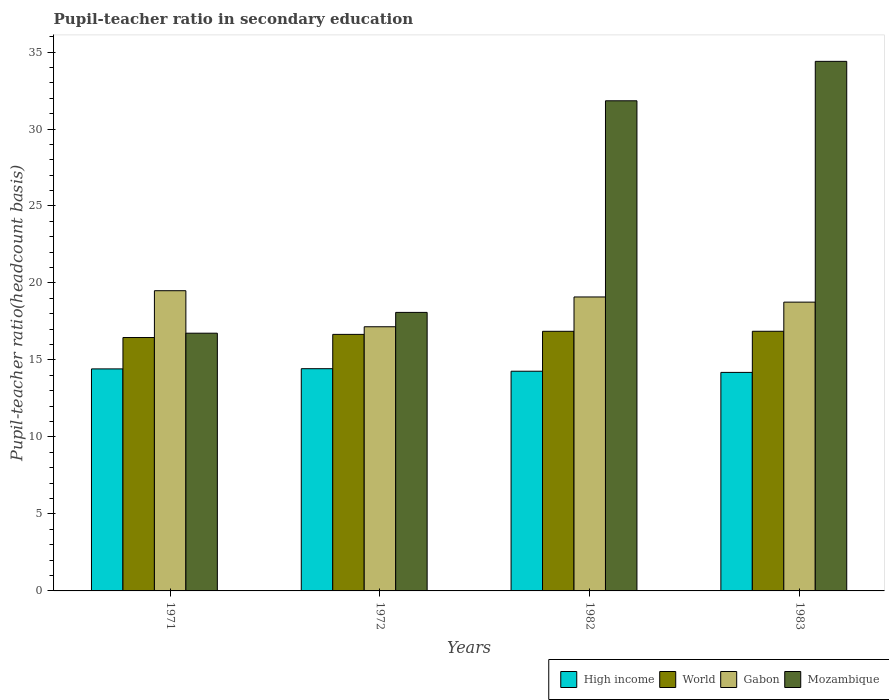How many different coloured bars are there?
Provide a succinct answer. 4. How many groups of bars are there?
Make the answer very short. 4. Are the number of bars on each tick of the X-axis equal?
Offer a very short reply. Yes. How many bars are there on the 3rd tick from the left?
Provide a short and direct response. 4. How many bars are there on the 2nd tick from the right?
Your response must be concise. 4. What is the label of the 2nd group of bars from the left?
Ensure brevity in your answer.  1972. What is the pupil-teacher ratio in secondary education in Mozambique in 1982?
Provide a short and direct response. 31.83. Across all years, what is the maximum pupil-teacher ratio in secondary education in World?
Ensure brevity in your answer.  16.86. Across all years, what is the minimum pupil-teacher ratio in secondary education in Mozambique?
Keep it short and to the point. 16.74. In which year was the pupil-teacher ratio in secondary education in Mozambique minimum?
Your answer should be compact. 1971. What is the total pupil-teacher ratio in secondary education in Mozambique in the graph?
Your response must be concise. 101.05. What is the difference between the pupil-teacher ratio in secondary education in High income in 1982 and that in 1983?
Ensure brevity in your answer.  0.08. What is the difference between the pupil-teacher ratio in secondary education in Gabon in 1972 and the pupil-teacher ratio in secondary education in World in 1983?
Offer a terse response. 0.29. What is the average pupil-teacher ratio in secondary education in Gabon per year?
Provide a succinct answer. 18.63. In the year 1982, what is the difference between the pupil-teacher ratio in secondary education in Gabon and pupil-teacher ratio in secondary education in World?
Offer a very short reply. 2.23. In how many years, is the pupil-teacher ratio in secondary education in World greater than 34?
Ensure brevity in your answer.  0. What is the ratio of the pupil-teacher ratio in secondary education in High income in 1972 to that in 1982?
Your answer should be very brief. 1.01. Is the pupil-teacher ratio in secondary education in High income in 1971 less than that in 1983?
Provide a succinct answer. No. Is the difference between the pupil-teacher ratio in secondary education in Gabon in 1971 and 1983 greater than the difference between the pupil-teacher ratio in secondary education in World in 1971 and 1983?
Make the answer very short. Yes. What is the difference between the highest and the second highest pupil-teacher ratio in secondary education in High income?
Offer a very short reply. 0.01. What is the difference between the highest and the lowest pupil-teacher ratio in secondary education in Mozambique?
Keep it short and to the point. 17.66. In how many years, is the pupil-teacher ratio in secondary education in High income greater than the average pupil-teacher ratio in secondary education in High income taken over all years?
Offer a terse response. 2. Is the sum of the pupil-teacher ratio in secondary education in High income in 1972 and 1982 greater than the maximum pupil-teacher ratio in secondary education in Mozambique across all years?
Your answer should be very brief. No. What does the 4th bar from the left in 1982 represents?
Offer a very short reply. Mozambique. Is it the case that in every year, the sum of the pupil-teacher ratio in secondary education in World and pupil-teacher ratio in secondary education in High income is greater than the pupil-teacher ratio in secondary education in Gabon?
Ensure brevity in your answer.  Yes. Are the values on the major ticks of Y-axis written in scientific E-notation?
Your response must be concise. No. Does the graph contain any zero values?
Your answer should be very brief. No. Does the graph contain grids?
Offer a terse response. No. How are the legend labels stacked?
Ensure brevity in your answer.  Horizontal. What is the title of the graph?
Provide a short and direct response. Pupil-teacher ratio in secondary education. Does "Tanzania" appear as one of the legend labels in the graph?
Your answer should be compact. No. What is the label or title of the X-axis?
Keep it short and to the point. Years. What is the label or title of the Y-axis?
Your answer should be compact. Pupil-teacher ratio(headcount basis). What is the Pupil-teacher ratio(headcount basis) of High income in 1971?
Ensure brevity in your answer.  14.42. What is the Pupil-teacher ratio(headcount basis) in World in 1971?
Give a very brief answer. 16.46. What is the Pupil-teacher ratio(headcount basis) of Gabon in 1971?
Your response must be concise. 19.5. What is the Pupil-teacher ratio(headcount basis) in Mozambique in 1971?
Keep it short and to the point. 16.74. What is the Pupil-teacher ratio(headcount basis) in High income in 1972?
Your answer should be very brief. 14.43. What is the Pupil-teacher ratio(headcount basis) in World in 1972?
Keep it short and to the point. 16.66. What is the Pupil-teacher ratio(headcount basis) in Gabon in 1972?
Give a very brief answer. 17.16. What is the Pupil-teacher ratio(headcount basis) of Mozambique in 1972?
Provide a short and direct response. 18.09. What is the Pupil-teacher ratio(headcount basis) in High income in 1982?
Offer a very short reply. 14.27. What is the Pupil-teacher ratio(headcount basis) in World in 1982?
Your answer should be compact. 16.86. What is the Pupil-teacher ratio(headcount basis) in Gabon in 1982?
Keep it short and to the point. 19.09. What is the Pupil-teacher ratio(headcount basis) of Mozambique in 1982?
Give a very brief answer. 31.83. What is the Pupil-teacher ratio(headcount basis) of High income in 1983?
Your answer should be very brief. 14.19. What is the Pupil-teacher ratio(headcount basis) of World in 1983?
Ensure brevity in your answer.  16.86. What is the Pupil-teacher ratio(headcount basis) in Gabon in 1983?
Ensure brevity in your answer.  18.76. What is the Pupil-teacher ratio(headcount basis) of Mozambique in 1983?
Give a very brief answer. 34.39. Across all years, what is the maximum Pupil-teacher ratio(headcount basis) of High income?
Offer a very short reply. 14.43. Across all years, what is the maximum Pupil-teacher ratio(headcount basis) in World?
Provide a short and direct response. 16.86. Across all years, what is the maximum Pupil-teacher ratio(headcount basis) in Gabon?
Offer a terse response. 19.5. Across all years, what is the maximum Pupil-teacher ratio(headcount basis) of Mozambique?
Offer a very short reply. 34.39. Across all years, what is the minimum Pupil-teacher ratio(headcount basis) in High income?
Offer a terse response. 14.19. Across all years, what is the minimum Pupil-teacher ratio(headcount basis) of World?
Provide a succinct answer. 16.46. Across all years, what is the minimum Pupil-teacher ratio(headcount basis) in Gabon?
Your answer should be very brief. 17.16. Across all years, what is the minimum Pupil-teacher ratio(headcount basis) in Mozambique?
Ensure brevity in your answer.  16.74. What is the total Pupil-teacher ratio(headcount basis) in High income in the graph?
Provide a succinct answer. 57.31. What is the total Pupil-teacher ratio(headcount basis) in World in the graph?
Make the answer very short. 66.84. What is the total Pupil-teacher ratio(headcount basis) in Gabon in the graph?
Offer a terse response. 74.5. What is the total Pupil-teacher ratio(headcount basis) of Mozambique in the graph?
Your answer should be compact. 101.06. What is the difference between the Pupil-teacher ratio(headcount basis) in High income in 1971 and that in 1972?
Provide a short and direct response. -0.01. What is the difference between the Pupil-teacher ratio(headcount basis) in World in 1971 and that in 1972?
Provide a short and direct response. -0.2. What is the difference between the Pupil-teacher ratio(headcount basis) of Gabon in 1971 and that in 1972?
Ensure brevity in your answer.  2.34. What is the difference between the Pupil-teacher ratio(headcount basis) in Mozambique in 1971 and that in 1972?
Provide a short and direct response. -1.35. What is the difference between the Pupil-teacher ratio(headcount basis) in High income in 1971 and that in 1982?
Provide a succinct answer. 0.15. What is the difference between the Pupil-teacher ratio(headcount basis) of World in 1971 and that in 1982?
Your answer should be very brief. -0.4. What is the difference between the Pupil-teacher ratio(headcount basis) of Gabon in 1971 and that in 1982?
Give a very brief answer. 0.41. What is the difference between the Pupil-teacher ratio(headcount basis) of Mozambique in 1971 and that in 1982?
Provide a succinct answer. -15.09. What is the difference between the Pupil-teacher ratio(headcount basis) of High income in 1971 and that in 1983?
Offer a very short reply. 0.23. What is the difference between the Pupil-teacher ratio(headcount basis) in World in 1971 and that in 1983?
Ensure brevity in your answer.  -0.41. What is the difference between the Pupil-teacher ratio(headcount basis) of Gabon in 1971 and that in 1983?
Give a very brief answer. 0.74. What is the difference between the Pupil-teacher ratio(headcount basis) in Mozambique in 1971 and that in 1983?
Offer a very short reply. -17.66. What is the difference between the Pupil-teacher ratio(headcount basis) of High income in 1972 and that in 1982?
Your answer should be very brief. 0.16. What is the difference between the Pupil-teacher ratio(headcount basis) of World in 1972 and that in 1982?
Give a very brief answer. -0.2. What is the difference between the Pupil-teacher ratio(headcount basis) of Gabon in 1972 and that in 1982?
Give a very brief answer. -1.93. What is the difference between the Pupil-teacher ratio(headcount basis) of Mozambique in 1972 and that in 1982?
Your answer should be compact. -13.74. What is the difference between the Pupil-teacher ratio(headcount basis) of High income in 1972 and that in 1983?
Your response must be concise. 0.24. What is the difference between the Pupil-teacher ratio(headcount basis) in World in 1972 and that in 1983?
Your answer should be compact. -0.2. What is the difference between the Pupil-teacher ratio(headcount basis) of Gabon in 1972 and that in 1983?
Your answer should be very brief. -1.6. What is the difference between the Pupil-teacher ratio(headcount basis) in Mozambique in 1972 and that in 1983?
Ensure brevity in your answer.  -16.3. What is the difference between the Pupil-teacher ratio(headcount basis) of High income in 1982 and that in 1983?
Provide a succinct answer. 0.08. What is the difference between the Pupil-teacher ratio(headcount basis) of World in 1982 and that in 1983?
Your response must be concise. -0. What is the difference between the Pupil-teacher ratio(headcount basis) of Gabon in 1982 and that in 1983?
Your response must be concise. 0.34. What is the difference between the Pupil-teacher ratio(headcount basis) of Mozambique in 1982 and that in 1983?
Offer a very short reply. -2.56. What is the difference between the Pupil-teacher ratio(headcount basis) in High income in 1971 and the Pupil-teacher ratio(headcount basis) in World in 1972?
Provide a succinct answer. -2.24. What is the difference between the Pupil-teacher ratio(headcount basis) of High income in 1971 and the Pupil-teacher ratio(headcount basis) of Gabon in 1972?
Offer a very short reply. -2.74. What is the difference between the Pupil-teacher ratio(headcount basis) of High income in 1971 and the Pupil-teacher ratio(headcount basis) of Mozambique in 1972?
Ensure brevity in your answer.  -3.67. What is the difference between the Pupil-teacher ratio(headcount basis) in World in 1971 and the Pupil-teacher ratio(headcount basis) in Gabon in 1972?
Offer a terse response. -0.7. What is the difference between the Pupil-teacher ratio(headcount basis) in World in 1971 and the Pupil-teacher ratio(headcount basis) in Mozambique in 1972?
Offer a terse response. -1.63. What is the difference between the Pupil-teacher ratio(headcount basis) in Gabon in 1971 and the Pupil-teacher ratio(headcount basis) in Mozambique in 1972?
Give a very brief answer. 1.41. What is the difference between the Pupil-teacher ratio(headcount basis) of High income in 1971 and the Pupil-teacher ratio(headcount basis) of World in 1982?
Your response must be concise. -2.44. What is the difference between the Pupil-teacher ratio(headcount basis) in High income in 1971 and the Pupil-teacher ratio(headcount basis) in Gabon in 1982?
Offer a very short reply. -4.67. What is the difference between the Pupil-teacher ratio(headcount basis) in High income in 1971 and the Pupil-teacher ratio(headcount basis) in Mozambique in 1982?
Your answer should be compact. -17.41. What is the difference between the Pupil-teacher ratio(headcount basis) in World in 1971 and the Pupil-teacher ratio(headcount basis) in Gabon in 1982?
Your response must be concise. -2.63. What is the difference between the Pupil-teacher ratio(headcount basis) in World in 1971 and the Pupil-teacher ratio(headcount basis) in Mozambique in 1982?
Ensure brevity in your answer.  -15.37. What is the difference between the Pupil-teacher ratio(headcount basis) in Gabon in 1971 and the Pupil-teacher ratio(headcount basis) in Mozambique in 1982?
Your answer should be compact. -12.33. What is the difference between the Pupil-teacher ratio(headcount basis) of High income in 1971 and the Pupil-teacher ratio(headcount basis) of World in 1983?
Ensure brevity in your answer.  -2.44. What is the difference between the Pupil-teacher ratio(headcount basis) in High income in 1971 and the Pupil-teacher ratio(headcount basis) in Gabon in 1983?
Provide a succinct answer. -4.34. What is the difference between the Pupil-teacher ratio(headcount basis) in High income in 1971 and the Pupil-teacher ratio(headcount basis) in Mozambique in 1983?
Your answer should be very brief. -19.97. What is the difference between the Pupil-teacher ratio(headcount basis) in World in 1971 and the Pupil-teacher ratio(headcount basis) in Gabon in 1983?
Keep it short and to the point. -2.3. What is the difference between the Pupil-teacher ratio(headcount basis) in World in 1971 and the Pupil-teacher ratio(headcount basis) in Mozambique in 1983?
Ensure brevity in your answer.  -17.94. What is the difference between the Pupil-teacher ratio(headcount basis) in Gabon in 1971 and the Pupil-teacher ratio(headcount basis) in Mozambique in 1983?
Keep it short and to the point. -14.9. What is the difference between the Pupil-teacher ratio(headcount basis) of High income in 1972 and the Pupil-teacher ratio(headcount basis) of World in 1982?
Ensure brevity in your answer.  -2.43. What is the difference between the Pupil-teacher ratio(headcount basis) in High income in 1972 and the Pupil-teacher ratio(headcount basis) in Gabon in 1982?
Keep it short and to the point. -4.66. What is the difference between the Pupil-teacher ratio(headcount basis) of High income in 1972 and the Pupil-teacher ratio(headcount basis) of Mozambique in 1982?
Give a very brief answer. -17.4. What is the difference between the Pupil-teacher ratio(headcount basis) in World in 1972 and the Pupil-teacher ratio(headcount basis) in Gabon in 1982?
Offer a terse response. -2.43. What is the difference between the Pupil-teacher ratio(headcount basis) in World in 1972 and the Pupil-teacher ratio(headcount basis) in Mozambique in 1982?
Make the answer very short. -15.17. What is the difference between the Pupil-teacher ratio(headcount basis) in Gabon in 1972 and the Pupil-teacher ratio(headcount basis) in Mozambique in 1982?
Keep it short and to the point. -14.68. What is the difference between the Pupil-teacher ratio(headcount basis) in High income in 1972 and the Pupil-teacher ratio(headcount basis) in World in 1983?
Keep it short and to the point. -2.43. What is the difference between the Pupil-teacher ratio(headcount basis) of High income in 1972 and the Pupil-teacher ratio(headcount basis) of Gabon in 1983?
Provide a short and direct response. -4.32. What is the difference between the Pupil-teacher ratio(headcount basis) in High income in 1972 and the Pupil-teacher ratio(headcount basis) in Mozambique in 1983?
Offer a very short reply. -19.96. What is the difference between the Pupil-teacher ratio(headcount basis) of World in 1972 and the Pupil-teacher ratio(headcount basis) of Gabon in 1983?
Offer a terse response. -2.09. What is the difference between the Pupil-teacher ratio(headcount basis) in World in 1972 and the Pupil-teacher ratio(headcount basis) in Mozambique in 1983?
Your answer should be very brief. -17.73. What is the difference between the Pupil-teacher ratio(headcount basis) of Gabon in 1972 and the Pupil-teacher ratio(headcount basis) of Mozambique in 1983?
Make the answer very short. -17.24. What is the difference between the Pupil-teacher ratio(headcount basis) in High income in 1982 and the Pupil-teacher ratio(headcount basis) in World in 1983?
Ensure brevity in your answer.  -2.59. What is the difference between the Pupil-teacher ratio(headcount basis) of High income in 1982 and the Pupil-teacher ratio(headcount basis) of Gabon in 1983?
Provide a succinct answer. -4.49. What is the difference between the Pupil-teacher ratio(headcount basis) in High income in 1982 and the Pupil-teacher ratio(headcount basis) in Mozambique in 1983?
Make the answer very short. -20.13. What is the difference between the Pupil-teacher ratio(headcount basis) of World in 1982 and the Pupil-teacher ratio(headcount basis) of Gabon in 1983?
Ensure brevity in your answer.  -1.89. What is the difference between the Pupil-teacher ratio(headcount basis) in World in 1982 and the Pupil-teacher ratio(headcount basis) in Mozambique in 1983?
Your answer should be very brief. -17.53. What is the difference between the Pupil-teacher ratio(headcount basis) of Gabon in 1982 and the Pupil-teacher ratio(headcount basis) of Mozambique in 1983?
Offer a terse response. -15.3. What is the average Pupil-teacher ratio(headcount basis) in High income per year?
Make the answer very short. 14.33. What is the average Pupil-teacher ratio(headcount basis) in World per year?
Give a very brief answer. 16.71. What is the average Pupil-teacher ratio(headcount basis) of Gabon per year?
Ensure brevity in your answer.  18.63. What is the average Pupil-teacher ratio(headcount basis) of Mozambique per year?
Provide a succinct answer. 25.26. In the year 1971, what is the difference between the Pupil-teacher ratio(headcount basis) of High income and Pupil-teacher ratio(headcount basis) of World?
Ensure brevity in your answer.  -2.04. In the year 1971, what is the difference between the Pupil-teacher ratio(headcount basis) of High income and Pupil-teacher ratio(headcount basis) of Gabon?
Your answer should be compact. -5.08. In the year 1971, what is the difference between the Pupil-teacher ratio(headcount basis) in High income and Pupil-teacher ratio(headcount basis) in Mozambique?
Provide a succinct answer. -2.32. In the year 1971, what is the difference between the Pupil-teacher ratio(headcount basis) of World and Pupil-teacher ratio(headcount basis) of Gabon?
Your response must be concise. -3.04. In the year 1971, what is the difference between the Pupil-teacher ratio(headcount basis) of World and Pupil-teacher ratio(headcount basis) of Mozambique?
Keep it short and to the point. -0.28. In the year 1971, what is the difference between the Pupil-teacher ratio(headcount basis) in Gabon and Pupil-teacher ratio(headcount basis) in Mozambique?
Ensure brevity in your answer.  2.76. In the year 1972, what is the difference between the Pupil-teacher ratio(headcount basis) of High income and Pupil-teacher ratio(headcount basis) of World?
Ensure brevity in your answer.  -2.23. In the year 1972, what is the difference between the Pupil-teacher ratio(headcount basis) in High income and Pupil-teacher ratio(headcount basis) in Gabon?
Your answer should be very brief. -2.72. In the year 1972, what is the difference between the Pupil-teacher ratio(headcount basis) of High income and Pupil-teacher ratio(headcount basis) of Mozambique?
Offer a terse response. -3.66. In the year 1972, what is the difference between the Pupil-teacher ratio(headcount basis) in World and Pupil-teacher ratio(headcount basis) in Gabon?
Give a very brief answer. -0.5. In the year 1972, what is the difference between the Pupil-teacher ratio(headcount basis) of World and Pupil-teacher ratio(headcount basis) of Mozambique?
Provide a short and direct response. -1.43. In the year 1972, what is the difference between the Pupil-teacher ratio(headcount basis) of Gabon and Pupil-teacher ratio(headcount basis) of Mozambique?
Your answer should be very brief. -0.93. In the year 1982, what is the difference between the Pupil-teacher ratio(headcount basis) of High income and Pupil-teacher ratio(headcount basis) of World?
Offer a terse response. -2.59. In the year 1982, what is the difference between the Pupil-teacher ratio(headcount basis) of High income and Pupil-teacher ratio(headcount basis) of Gabon?
Ensure brevity in your answer.  -4.82. In the year 1982, what is the difference between the Pupil-teacher ratio(headcount basis) in High income and Pupil-teacher ratio(headcount basis) in Mozambique?
Provide a short and direct response. -17.56. In the year 1982, what is the difference between the Pupil-teacher ratio(headcount basis) in World and Pupil-teacher ratio(headcount basis) in Gabon?
Provide a short and direct response. -2.23. In the year 1982, what is the difference between the Pupil-teacher ratio(headcount basis) of World and Pupil-teacher ratio(headcount basis) of Mozambique?
Keep it short and to the point. -14.97. In the year 1982, what is the difference between the Pupil-teacher ratio(headcount basis) of Gabon and Pupil-teacher ratio(headcount basis) of Mozambique?
Your answer should be very brief. -12.74. In the year 1983, what is the difference between the Pupil-teacher ratio(headcount basis) of High income and Pupil-teacher ratio(headcount basis) of World?
Provide a short and direct response. -2.67. In the year 1983, what is the difference between the Pupil-teacher ratio(headcount basis) in High income and Pupil-teacher ratio(headcount basis) in Gabon?
Ensure brevity in your answer.  -4.56. In the year 1983, what is the difference between the Pupil-teacher ratio(headcount basis) of High income and Pupil-teacher ratio(headcount basis) of Mozambique?
Keep it short and to the point. -20.2. In the year 1983, what is the difference between the Pupil-teacher ratio(headcount basis) in World and Pupil-teacher ratio(headcount basis) in Gabon?
Your answer should be compact. -1.89. In the year 1983, what is the difference between the Pupil-teacher ratio(headcount basis) in World and Pupil-teacher ratio(headcount basis) in Mozambique?
Provide a short and direct response. -17.53. In the year 1983, what is the difference between the Pupil-teacher ratio(headcount basis) of Gabon and Pupil-teacher ratio(headcount basis) of Mozambique?
Provide a short and direct response. -15.64. What is the ratio of the Pupil-teacher ratio(headcount basis) of World in 1971 to that in 1972?
Your response must be concise. 0.99. What is the ratio of the Pupil-teacher ratio(headcount basis) in Gabon in 1971 to that in 1972?
Make the answer very short. 1.14. What is the ratio of the Pupil-teacher ratio(headcount basis) of Mozambique in 1971 to that in 1972?
Ensure brevity in your answer.  0.93. What is the ratio of the Pupil-teacher ratio(headcount basis) of High income in 1971 to that in 1982?
Ensure brevity in your answer.  1.01. What is the ratio of the Pupil-teacher ratio(headcount basis) in Gabon in 1971 to that in 1982?
Make the answer very short. 1.02. What is the ratio of the Pupil-teacher ratio(headcount basis) in Mozambique in 1971 to that in 1982?
Ensure brevity in your answer.  0.53. What is the ratio of the Pupil-teacher ratio(headcount basis) in High income in 1971 to that in 1983?
Make the answer very short. 1.02. What is the ratio of the Pupil-teacher ratio(headcount basis) in World in 1971 to that in 1983?
Your response must be concise. 0.98. What is the ratio of the Pupil-teacher ratio(headcount basis) in Gabon in 1971 to that in 1983?
Offer a terse response. 1.04. What is the ratio of the Pupil-teacher ratio(headcount basis) in Mozambique in 1971 to that in 1983?
Provide a succinct answer. 0.49. What is the ratio of the Pupil-teacher ratio(headcount basis) in High income in 1972 to that in 1982?
Offer a very short reply. 1.01. What is the ratio of the Pupil-teacher ratio(headcount basis) of Gabon in 1972 to that in 1982?
Make the answer very short. 0.9. What is the ratio of the Pupil-teacher ratio(headcount basis) in Mozambique in 1972 to that in 1982?
Your answer should be very brief. 0.57. What is the ratio of the Pupil-teacher ratio(headcount basis) in High income in 1972 to that in 1983?
Provide a succinct answer. 1.02. What is the ratio of the Pupil-teacher ratio(headcount basis) of World in 1972 to that in 1983?
Your answer should be compact. 0.99. What is the ratio of the Pupil-teacher ratio(headcount basis) in Gabon in 1972 to that in 1983?
Make the answer very short. 0.91. What is the ratio of the Pupil-teacher ratio(headcount basis) in Mozambique in 1972 to that in 1983?
Offer a very short reply. 0.53. What is the ratio of the Pupil-teacher ratio(headcount basis) of High income in 1982 to that in 1983?
Give a very brief answer. 1.01. What is the ratio of the Pupil-teacher ratio(headcount basis) of World in 1982 to that in 1983?
Ensure brevity in your answer.  1. What is the ratio of the Pupil-teacher ratio(headcount basis) of Gabon in 1982 to that in 1983?
Ensure brevity in your answer.  1.02. What is the ratio of the Pupil-teacher ratio(headcount basis) in Mozambique in 1982 to that in 1983?
Provide a short and direct response. 0.93. What is the difference between the highest and the second highest Pupil-teacher ratio(headcount basis) of High income?
Ensure brevity in your answer.  0.01. What is the difference between the highest and the second highest Pupil-teacher ratio(headcount basis) of World?
Your answer should be very brief. 0. What is the difference between the highest and the second highest Pupil-teacher ratio(headcount basis) in Gabon?
Offer a terse response. 0.41. What is the difference between the highest and the second highest Pupil-teacher ratio(headcount basis) of Mozambique?
Provide a succinct answer. 2.56. What is the difference between the highest and the lowest Pupil-teacher ratio(headcount basis) of High income?
Offer a very short reply. 0.24. What is the difference between the highest and the lowest Pupil-teacher ratio(headcount basis) of World?
Your answer should be compact. 0.41. What is the difference between the highest and the lowest Pupil-teacher ratio(headcount basis) in Gabon?
Your answer should be compact. 2.34. What is the difference between the highest and the lowest Pupil-teacher ratio(headcount basis) of Mozambique?
Provide a succinct answer. 17.66. 